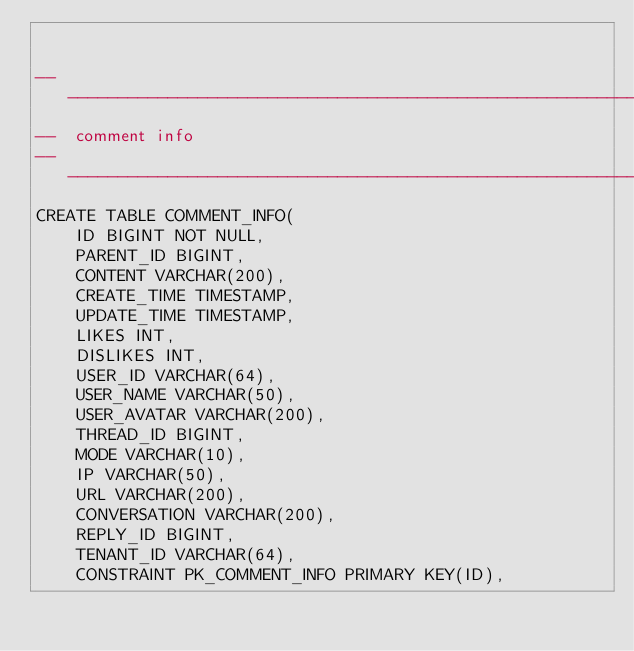Convert code to text. <code><loc_0><loc_0><loc_500><loc_500><_SQL_>

-------------------------------------------------------------------------------
--  comment info
-------------------------------------------------------------------------------
CREATE TABLE COMMENT_INFO(
    ID BIGINT NOT NULL,
	PARENT_ID BIGINT,
	CONTENT VARCHAR(200),
    CREATE_TIME TIMESTAMP,
    UPDATE_TIME TIMESTAMP,
    LIKES INT,
    DISLIKES INT,
    USER_ID VARCHAR(64),
    USER_NAME VARCHAR(50),
    USER_AVATAR VARCHAR(200),
    THREAD_ID BIGINT,
    MODE VARCHAR(10),
    IP VARCHAR(50),
    URL VARCHAR(200),
    CONVERSATION VARCHAR(200),
    REPLY_ID BIGINT,
	TENANT_ID VARCHAR(64),
    CONSTRAINT PK_COMMENT_INFO PRIMARY KEY(ID),</code> 